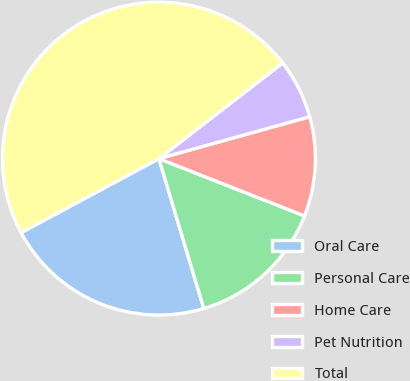<chart> <loc_0><loc_0><loc_500><loc_500><pie_chart><fcel>Oral Care<fcel>Personal Care<fcel>Home Care<fcel>Pet Nutrition<fcel>Total<nl><fcel>21.79%<fcel>14.4%<fcel>10.28%<fcel>6.16%<fcel>47.37%<nl></chart> 